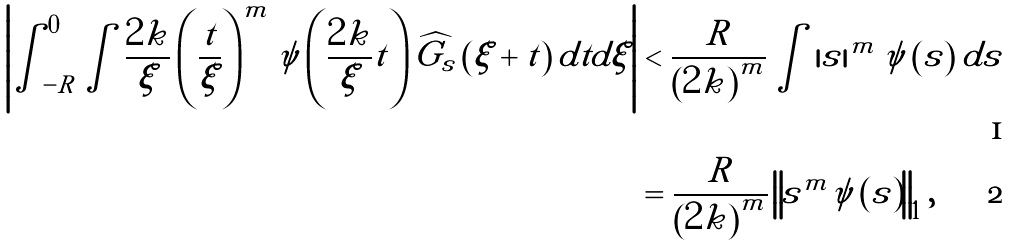Convert formula to latex. <formula><loc_0><loc_0><loc_500><loc_500>\left | \int _ { - R } ^ { 0 } \int \frac { 2 k } { \xi } \left ( \frac { t } { \xi } \right ) ^ { m } \psi \left ( \frac { 2 k } { \xi } t \right ) \widehat { G _ { s } } \left ( \xi + t \right ) d t d \xi \right | & < \frac { R } { \left ( 2 k \right ) ^ { m } } \int \left | s \right | ^ { m } \psi \left ( s \right ) d s \\ & = \frac { R } { \left ( 2 k \right ) ^ { m } } \left \| s ^ { m } \psi \left ( s \right ) \right \| _ { 1 } ,</formula> 